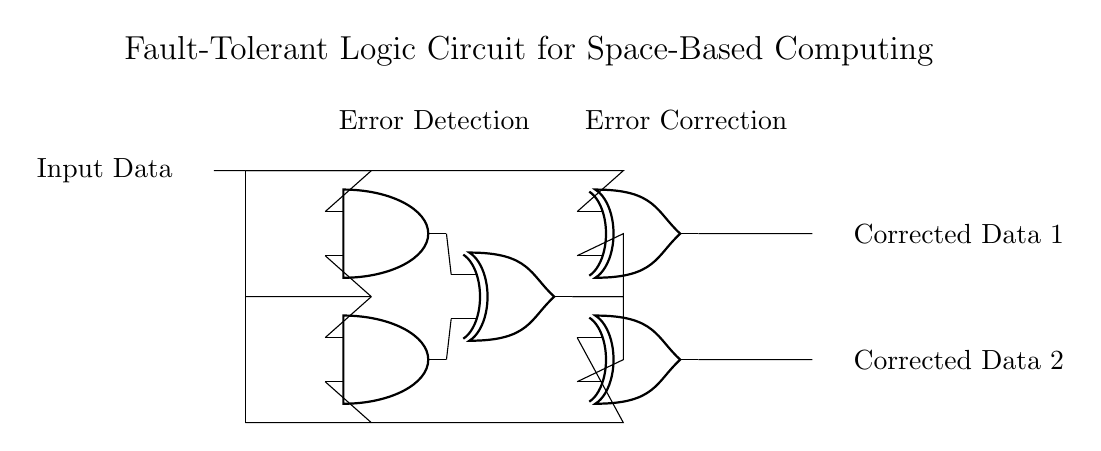What are the main components used in this circuit? The circuit contains AND gates, XOR gates, and input/output connections. Each gate is represented visually, and the connections among them indicate how the circuit processes data.
Answer: AND gates, XOR gates What is the purpose of the XOR gates in this circuit? The XOR gates are used for both error detection and correction. They take the outputs from the AND gates and provide corrected data based on the input signals.
Answer: Error detection and correction How many output lines are there in this circuit? The circuit has two output lines as indicated by "Corrected Data 1" and "Corrected Data 2" located on the right side of the diagram.
Answer: Two Describe the function of the AND gates in this circuit. The AND gates are used to compare the input data signals for error detection. Each gate processes two input lines and provides an output based on logical conjunction, which contributes to the overall error correction process.
Answer: Error detection What can be inferred about the input data from the structure of the circuit? The input data is required to pass through both the error detection and error correction stages, indicating that the circuit is designed to ensure data integrity before producing the corrected outputs.
Answer: Data integrity assurance What does the label "Error Correction" signify about that section of the circuit? The label indicates that the section under it is responsible for correcting any errors detected in the previous stage. The XOR gates work together to process the error outputs and produce corrected results.
Answer: Correcting errors 